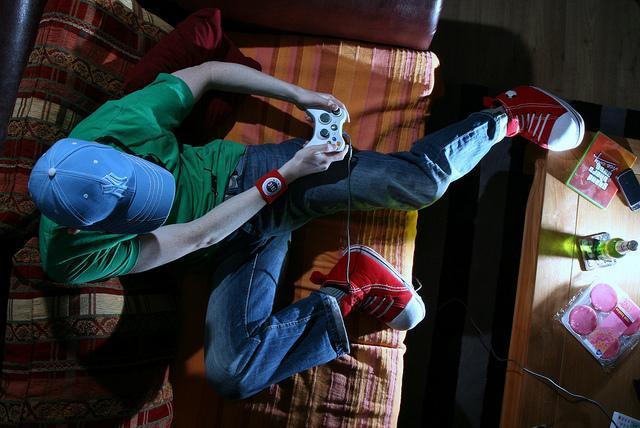How many dining tables are visible?
Give a very brief answer. 1. 